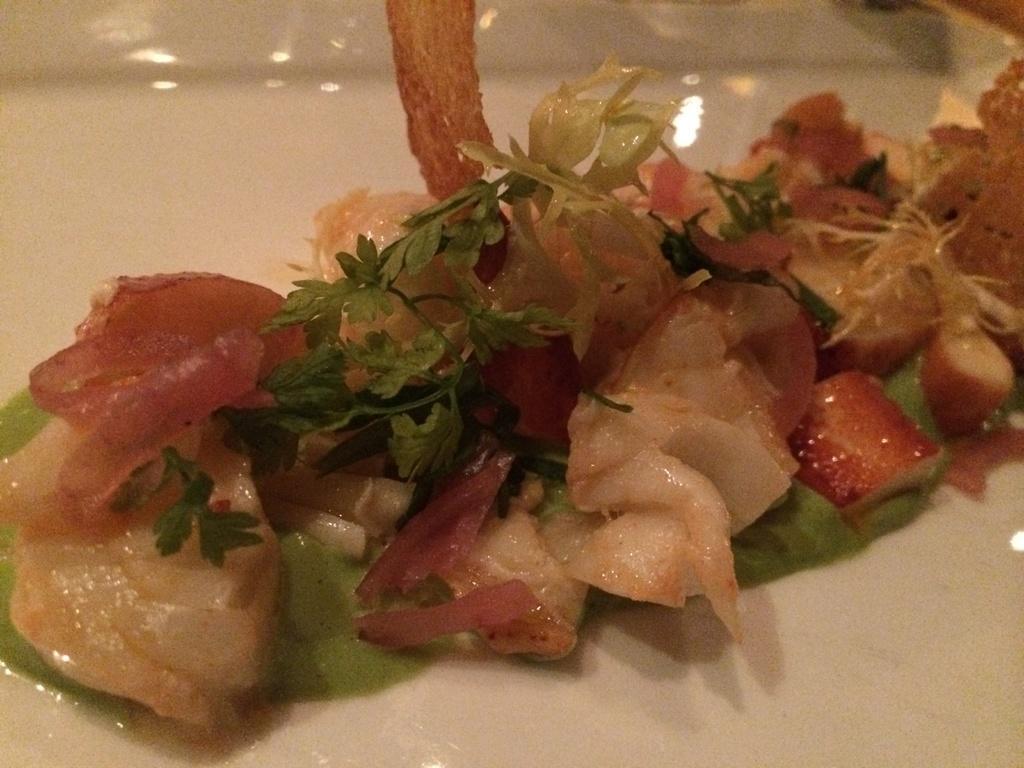Please provide a concise description of this image. In this image I can see a white colored plate and on the white colored plate I can see a food item which includes few tomato pieces which are red in color and few herbs which are green in color and few other ingredients. 